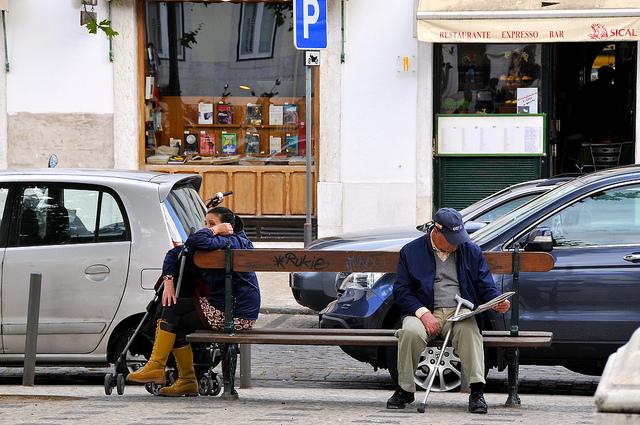How many people are on the bench?
Quick response, please. 2. Is the woman wearing sneakers?
Quick response, please. No. What is the man reading?
Short answer required. Newspaper. 